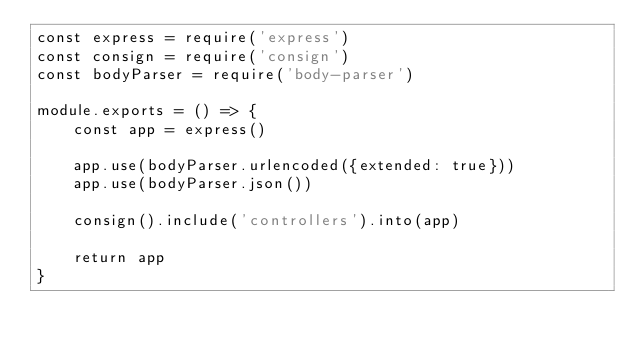<code> <loc_0><loc_0><loc_500><loc_500><_JavaScript_>const express = require('express')
const consign = require('consign')
const bodyParser = require('body-parser')

module.exports = () => {
    const app = express()

    app.use(bodyParser.urlencoded({extended: true}))
    app.use(bodyParser.json())

    consign().include('controllers').into(app)

    return app
}
</code> 